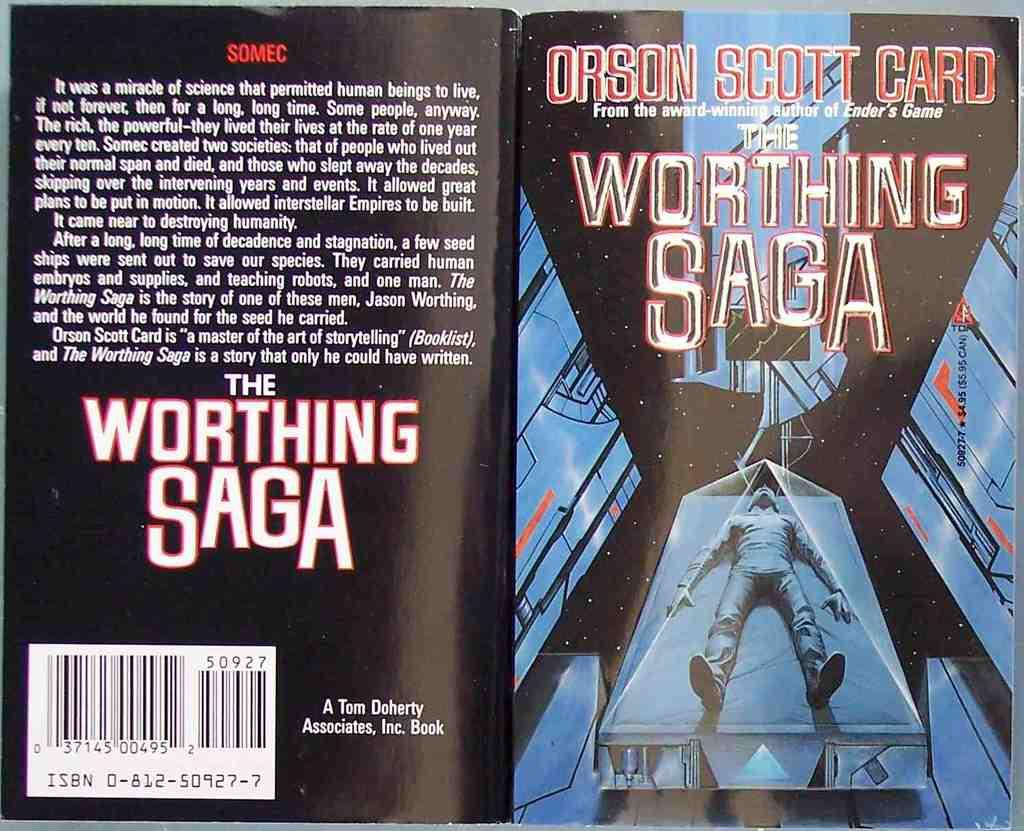Provide a one-sentence caption for the provided image. The working saga a book by Orson Scott Card. 